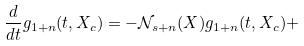Convert formula to latex. <formula><loc_0><loc_0><loc_500><loc_500>\frac { d } { d t } g _ { 1 + n } ( t , X _ { c } ) = - \mathcal { N } _ { s + n } ( X ) g _ { 1 + n } ( t , X _ { c } ) +</formula> 